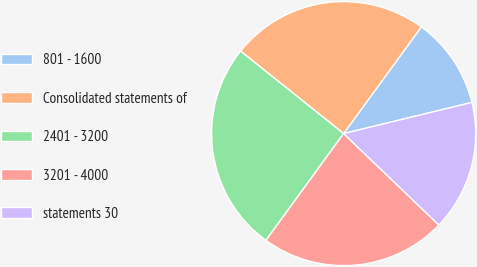Convert chart. <chart><loc_0><loc_0><loc_500><loc_500><pie_chart><fcel>801 - 1600<fcel>Consolidated statements of<fcel>2401 - 3200<fcel>3201 - 4000<fcel>statements 30<nl><fcel>11.19%<fcel>24.28%<fcel>25.73%<fcel>22.84%<fcel>15.96%<nl></chart> 